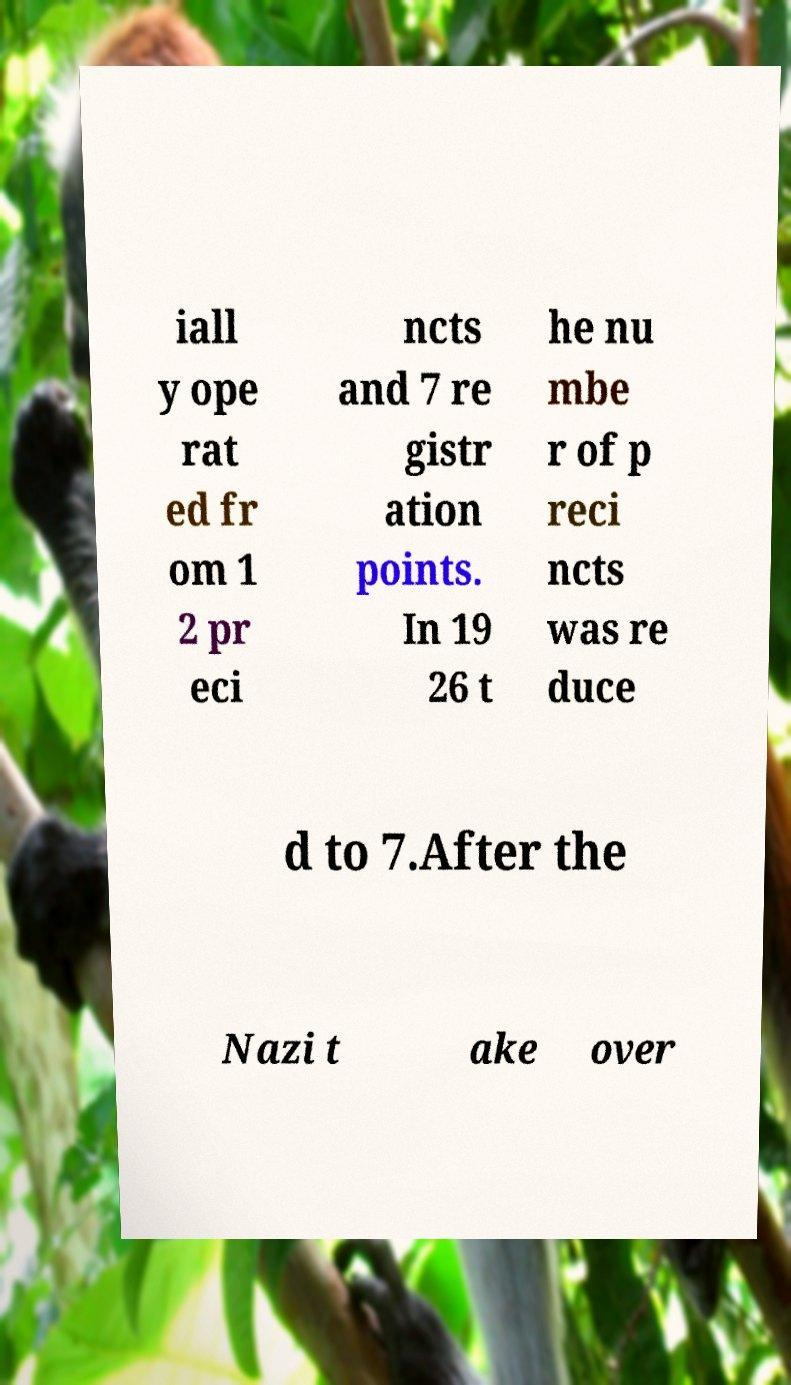What messages or text are displayed in this image? I need them in a readable, typed format. iall y ope rat ed fr om 1 2 pr eci ncts and 7 re gistr ation points. In 19 26 t he nu mbe r of p reci ncts was re duce d to 7.After the Nazi t ake over 